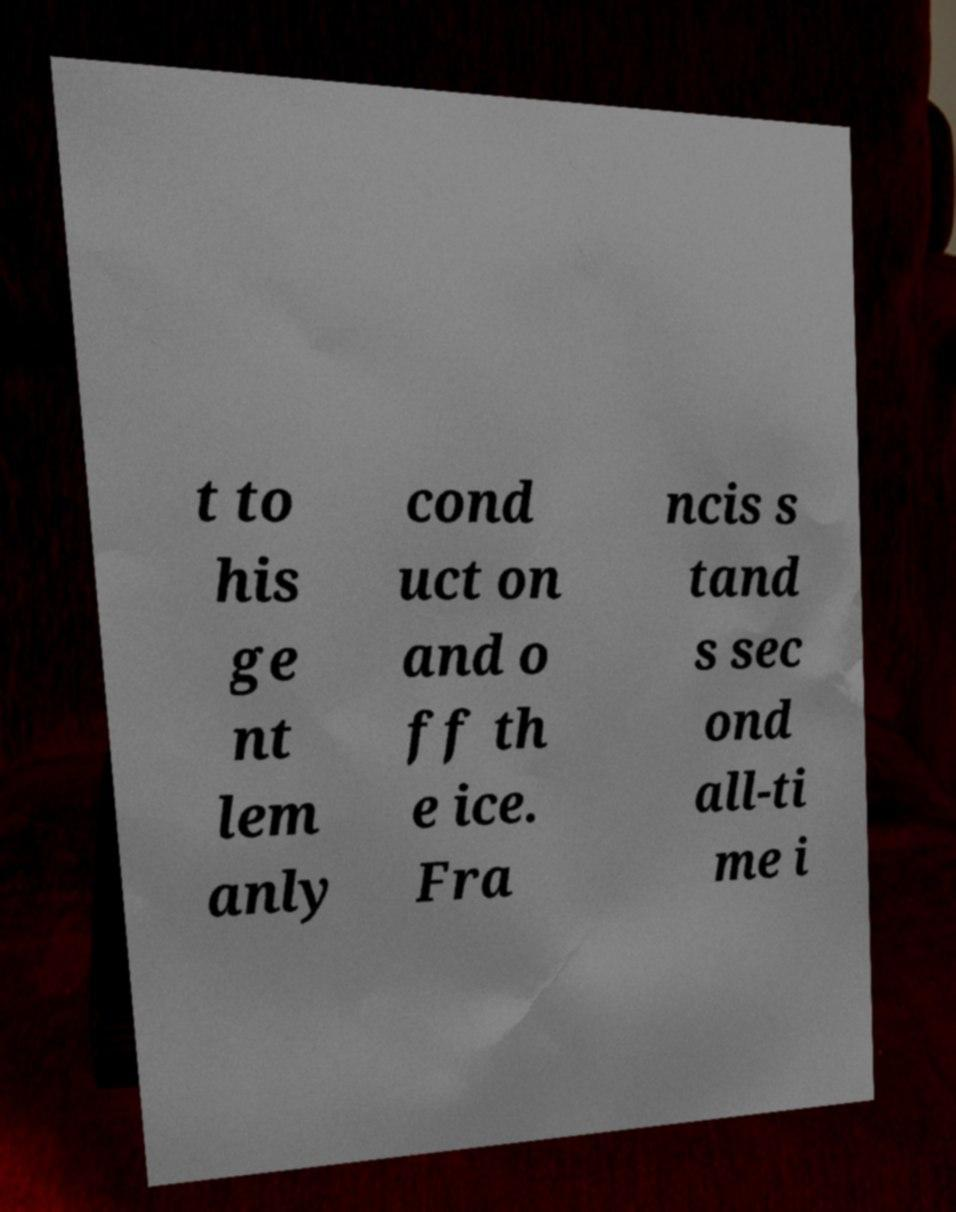I need the written content from this picture converted into text. Can you do that? t to his ge nt lem anly cond uct on and o ff th e ice. Fra ncis s tand s sec ond all-ti me i 